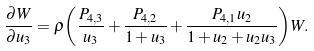Convert formula to latex. <formula><loc_0><loc_0><loc_500><loc_500>\frac { { \partial } W } { { \partial } u _ { 3 } } = \rho { \left ( \frac { P _ { 4 , 3 } } { u _ { 3 } } + \frac { P _ { 4 , 2 } } { 1 + u _ { 3 } } + \frac { P _ { 4 , 1 } u _ { 2 } } { 1 + u _ { 2 } + u _ { 2 } u _ { 3 } } \right ) } W .</formula> 